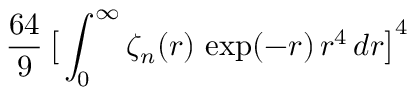Convert formula to latex. <formula><loc_0><loc_0><loc_500><loc_500>\frac { 6 4 } { 9 } \, \left [ \int _ { 0 } ^ { \infty } \zeta _ { n } ( r ) \, \exp ( - r ) \, r ^ { 4 } \, d r \right ] ^ { 4 }</formula> 